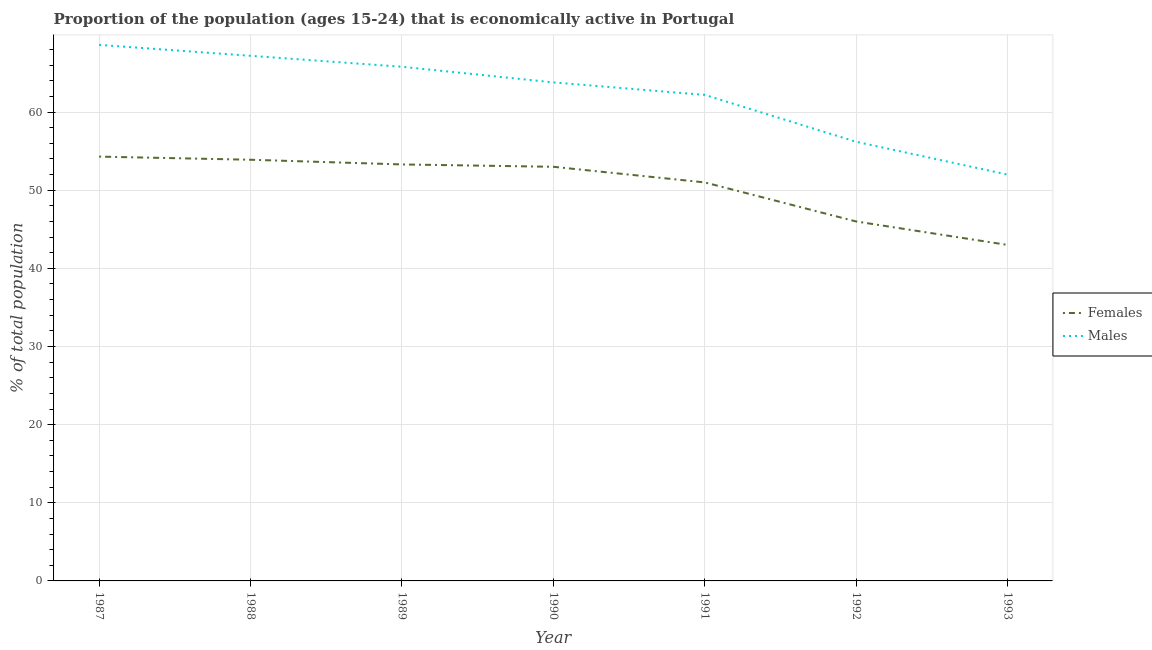Is the number of lines equal to the number of legend labels?
Your response must be concise. Yes. Across all years, what is the maximum percentage of economically active female population?
Provide a short and direct response. 54.3. Across all years, what is the minimum percentage of economically active female population?
Your answer should be compact. 43. In which year was the percentage of economically active female population minimum?
Offer a terse response. 1993. What is the total percentage of economically active male population in the graph?
Your response must be concise. 435.8. What is the difference between the percentage of economically active male population in 1987 and that in 1989?
Offer a terse response. 2.8. What is the difference between the percentage of economically active male population in 1991 and the percentage of economically active female population in 1993?
Offer a terse response. 19.2. What is the average percentage of economically active female population per year?
Offer a terse response. 50.64. In the year 1992, what is the difference between the percentage of economically active male population and percentage of economically active female population?
Make the answer very short. 10.2. In how many years, is the percentage of economically active female population greater than 16 %?
Your answer should be very brief. 7. What is the ratio of the percentage of economically active female population in 1990 to that in 1992?
Provide a short and direct response. 1.15. Is the percentage of economically active female population in 1987 less than that in 1992?
Your answer should be compact. No. Is the difference between the percentage of economically active female population in 1987 and 1991 greater than the difference between the percentage of economically active male population in 1987 and 1991?
Your response must be concise. No. What is the difference between the highest and the second highest percentage of economically active male population?
Provide a succinct answer. 1.4. What is the difference between the highest and the lowest percentage of economically active male population?
Provide a short and direct response. 16.6. In how many years, is the percentage of economically active male population greater than the average percentage of economically active male population taken over all years?
Give a very brief answer. 4. Is the sum of the percentage of economically active male population in 1988 and 1993 greater than the maximum percentage of economically active female population across all years?
Provide a short and direct response. Yes. How many years are there in the graph?
Make the answer very short. 7. What is the difference between two consecutive major ticks on the Y-axis?
Provide a succinct answer. 10. Are the values on the major ticks of Y-axis written in scientific E-notation?
Provide a succinct answer. No. Does the graph contain grids?
Make the answer very short. Yes. Where does the legend appear in the graph?
Provide a succinct answer. Center right. How many legend labels are there?
Keep it short and to the point. 2. How are the legend labels stacked?
Make the answer very short. Vertical. What is the title of the graph?
Give a very brief answer. Proportion of the population (ages 15-24) that is economically active in Portugal. What is the label or title of the Y-axis?
Give a very brief answer. % of total population. What is the % of total population in Females in 1987?
Your answer should be very brief. 54.3. What is the % of total population of Males in 1987?
Offer a terse response. 68.6. What is the % of total population of Females in 1988?
Give a very brief answer. 53.9. What is the % of total population in Males in 1988?
Your answer should be very brief. 67.2. What is the % of total population in Females in 1989?
Your answer should be very brief. 53.3. What is the % of total population of Males in 1989?
Provide a short and direct response. 65.8. What is the % of total population in Males in 1990?
Ensure brevity in your answer.  63.8. What is the % of total population of Females in 1991?
Your response must be concise. 51. What is the % of total population of Males in 1991?
Your answer should be compact. 62.2. What is the % of total population of Males in 1992?
Make the answer very short. 56.2. What is the % of total population in Females in 1993?
Keep it short and to the point. 43. Across all years, what is the maximum % of total population of Females?
Ensure brevity in your answer.  54.3. Across all years, what is the maximum % of total population in Males?
Give a very brief answer. 68.6. Across all years, what is the minimum % of total population in Females?
Make the answer very short. 43. Across all years, what is the minimum % of total population in Males?
Make the answer very short. 52. What is the total % of total population in Females in the graph?
Offer a very short reply. 354.5. What is the total % of total population of Males in the graph?
Give a very brief answer. 435.8. What is the difference between the % of total population in Females in 1987 and that in 1988?
Make the answer very short. 0.4. What is the difference between the % of total population of Males in 1987 and that in 1988?
Offer a very short reply. 1.4. What is the difference between the % of total population of Females in 1987 and that in 1989?
Keep it short and to the point. 1. What is the difference between the % of total population in Males in 1987 and that in 1989?
Give a very brief answer. 2.8. What is the difference between the % of total population of Females in 1987 and that in 1990?
Provide a succinct answer. 1.3. What is the difference between the % of total population of Males in 1987 and that in 1990?
Ensure brevity in your answer.  4.8. What is the difference between the % of total population in Females in 1987 and that in 1991?
Your answer should be compact. 3.3. What is the difference between the % of total population in Males in 1988 and that in 1990?
Make the answer very short. 3.4. What is the difference between the % of total population of Females in 1988 and that in 1992?
Your response must be concise. 7.9. What is the difference between the % of total population in Males in 1988 and that in 1992?
Your answer should be very brief. 11. What is the difference between the % of total population of Females in 1989 and that in 1991?
Provide a succinct answer. 2.3. What is the difference between the % of total population of Females in 1989 and that in 1992?
Your answer should be very brief. 7.3. What is the difference between the % of total population in Females in 1989 and that in 1993?
Ensure brevity in your answer.  10.3. What is the difference between the % of total population of Males in 1990 and that in 1991?
Offer a terse response. 1.6. What is the difference between the % of total population of Females in 1990 and that in 1992?
Keep it short and to the point. 7. What is the difference between the % of total population of Females in 1991 and that in 1992?
Your response must be concise. 5. What is the difference between the % of total population in Females in 1991 and that in 1993?
Your response must be concise. 8. What is the difference between the % of total population in Males in 1991 and that in 1993?
Make the answer very short. 10.2. What is the difference between the % of total population of Females in 1992 and that in 1993?
Keep it short and to the point. 3. What is the difference between the % of total population of Females in 1987 and the % of total population of Males in 1989?
Your response must be concise. -11.5. What is the difference between the % of total population of Females in 1987 and the % of total population of Males in 1990?
Offer a terse response. -9.5. What is the difference between the % of total population in Females in 1987 and the % of total population in Males in 1991?
Ensure brevity in your answer.  -7.9. What is the difference between the % of total population of Females in 1987 and the % of total population of Males in 1992?
Make the answer very short. -1.9. What is the difference between the % of total population of Females in 1988 and the % of total population of Males in 1989?
Ensure brevity in your answer.  -11.9. What is the difference between the % of total population in Females in 1988 and the % of total population in Males in 1990?
Ensure brevity in your answer.  -9.9. What is the difference between the % of total population of Females in 1988 and the % of total population of Males in 1993?
Provide a short and direct response. 1.9. What is the difference between the % of total population of Females in 1989 and the % of total population of Males in 1992?
Provide a short and direct response. -2.9. What is the difference between the % of total population of Females in 1989 and the % of total population of Males in 1993?
Your answer should be compact. 1.3. What is the difference between the % of total population in Females in 1990 and the % of total population in Males in 1991?
Provide a succinct answer. -9.2. What is the difference between the % of total population of Females in 1991 and the % of total population of Males in 1992?
Provide a short and direct response. -5.2. What is the difference between the % of total population of Females in 1992 and the % of total population of Males in 1993?
Give a very brief answer. -6. What is the average % of total population in Females per year?
Keep it short and to the point. 50.64. What is the average % of total population of Males per year?
Offer a terse response. 62.26. In the year 1987, what is the difference between the % of total population in Females and % of total population in Males?
Ensure brevity in your answer.  -14.3. In the year 1988, what is the difference between the % of total population in Females and % of total population in Males?
Your answer should be very brief. -13.3. In the year 1990, what is the difference between the % of total population of Females and % of total population of Males?
Your response must be concise. -10.8. In the year 1991, what is the difference between the % of total population of Females and % of total population of Males?
Your response must be concise. -11.2. In the year 1992, what is the difference between the % of total population of Females and % of total population of Males?
Offer a very short reply. -10.2. In the year 1993, what is the difference between the % of total population of Females and % of total population of Males?
Ensure brevity in your answer.  -9. What is the ratio of the % of total population in Females in 1987 to that in 1988?
Keep it short and to the point. 1.01. What is the ratio of the % of total population in Males in 1987 to that in 1988?
Your answer should be compact. 1.02. What is the ratio of the % of total population of Females in 1987 to that in 1989?
Provide a succinct answer. 1.02. What is the ratio of the % of total population of Males in 1987 to that in 1989?
Provide a short and direct response. 1.04. What is the ratio of the % of total population of Females in 1987 to that in 1990?
Ensure brevity in your answer.  1.02. What is the ratio of the % of total population in Males in 1987 to that in 1990?
Provide a short and direct response. 1.08. What is the ratio of the % of total population of Females in 1987 to that in 1991?
Give a very brief answer. 1.06. What is the ratio of the % of total population of Males in 1987 to that in 1991?
Make the answer very short. 1.1. What is the ratio of the % of total population of Females in 1987 to that in 1992?
Your response must be concise. 1.18. What is the ratio of the % of total population in Males in 1987 to that in 1992?
Your answer should be compact. 1.22. What is the ratio of the % of total population of Females in 1987 to that in 1993?
Keep it short and to the point. 1.26. What is the ratio of the % of total population of Males in 1987 to that in 1993?
Ensure brevity in your answer.  1.32. What is the ratio of the % of total population in Females in 1988 to that in 1989?
Offer a terse response. 1.01. What is the ratio of the % of total population of Males in 1988 to that in 1989?
Provide a short and direct response. 1.02. What is the ratio of the % of total population in Females in 1988 to that in 1990?
Ensure brevity in your answer.  1.02. What is the ratio of the % of total population in Males in 1988 to that in 1990?
Your response must be concise. 1.05. What is the ratio of the % of total population in Females in 1988 to that in 1991?
Give a very brief answer. 1.06. What is the ratio of the % of total population in Males in 1988 to that in 1991?
Your response must be concise. 1.08. What is the ratio of the % of total population of Females in 1988 to that in 1992?
Your answer should be very brief. 1.17. What is the ratio of the % of total population in Males in 1988 to that in 1992?
Offer a very short reply. 1.2. What is the ratio of the % of total population in Females in 1988 to that in 1993?
Your answer should be compact. 1.25. What is the ratio of the % of total population in Males in 1988 to that in 1993?
Ensure brevity in your answer.  1.29. What is the ratio of the % of total population of Males in 1989 to that in 1990?
Offer a terse response. 1.03. What is the ratio of the % of total population in Females in 1989 to that in 1991?
Keep it short and to the point. 1.05. What is the ratio of the % of total population in Males in 1989 to that in 1991?
Provide a short and direct response. 1.06. What is the ratio of the % of total population of Females in 1989 to that in 1992?
Provide a succinct answer. 1.16. What is the ratio of the % of total population in Males in 1989 to that in 1992?
Your answer should be very brief. 1.17. What is the ratio of the % of total population of Females in 1989 to that in 1993?
Provide a succinct answer. 1.24. What is the ratio of the % of total population in Males in 1989 to that in 1993?
Your answer should be very brief. 1.27. What is the ratio of the % of total population in Females in 1990 to that in 1991?
Give a very brief answer. 1.04. What is the ratio of the % of total population of Males in 1990 to that in 1991?
Offer a very short reply. 1.03. What is the ratio of the % of total population in Females in 1990 to that in 1992?
Offer a very short reply. 1.15. What is the ratio of the % of total population in Males in 1990 to that in 1992?
Your answer should be compact. 1.14. What is the ratio of the % of total population in Females in 1990 to that in 1993?
Offer a terse response. 1.23. What is the ratio of the % of total population in Males in 1990 to that in 1993?
Make the answer very short. 1.23. What is the ratio of the % of total population of Females in 1991 to that in 1992?
Your answer should be compact. 1.11. What is the ratio of the % of total population of Males in 1991 to that in 1992?
Offer a terse response. 1.11. What is the ratio of the % of total population in Females in 1991 to that in 1993?
Your answer should be compact. 1.19. What is the ratio of the % of total population in Males in 1991 to that in 1993?
Offer a very short reply. 1.2. What is the ratio of the % of total population of Females in 1992 to that in 1993?
Offer a terse response. 1.07. What is the ratio of the % of total population of Males in 1992 to that in 1993?
Offer a terse response. 1.08. What is the difference between the highest and the second highest % of total population of Females?
Offer a terse response. 0.4. What is the difference between the highest and the lowest % of total population in Females?
Provide a succinct answer. 11.3. What is the difference between the highest and the lowest % of total population of Males?
Keep it short and to the point. 16.6. 